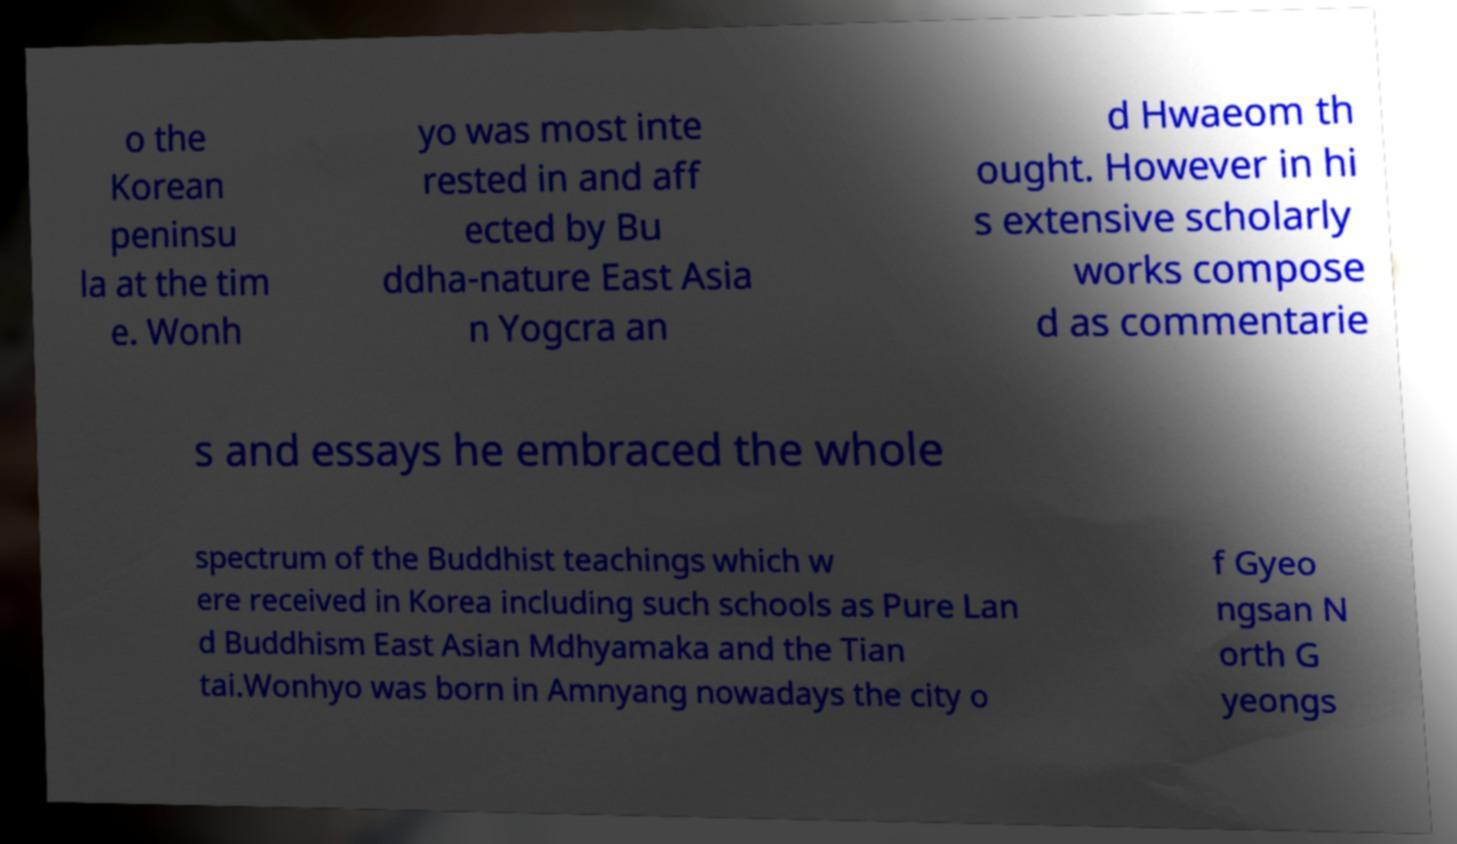I need the written content from this picture converted into text. Can you do that? o the Korean peninsu la at the tim e. Wonh yo was most inte rested in and aff ected by Bu ddha-nature East Asia n Yogcra an d Hwaeom th ought. However in hi s extensive scholarly works compose d as commentarie s and essays he embraced the whole spectrum of the Buddhist teachings which w ere received in Korea including such schools as Pure Lan d Buddhism East Asian Mdhyamaka and the Tian tai.Wonhyo was born in Amnyang nowadays the city o f Gyeo ngsan N orth G yeongs 